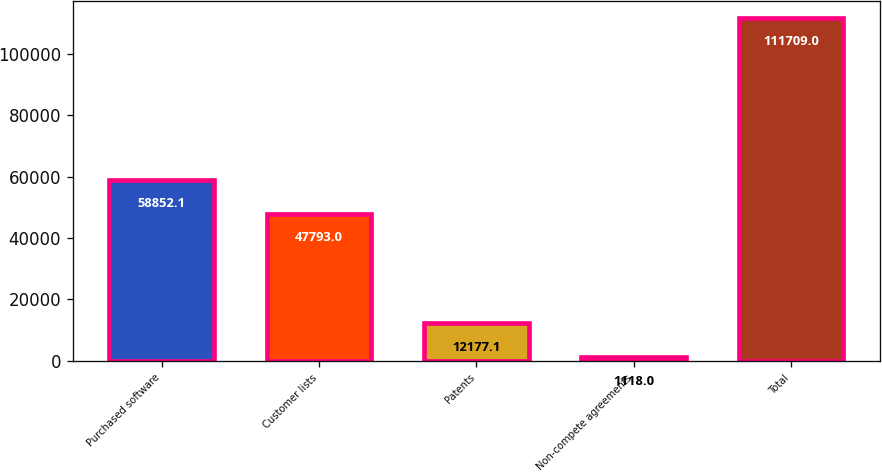Convert chart. <chart><loc_0><loc_0><loc_500><loc_500><bar_chart><fcel>Purchased software<fcel>Customer lists<fcel>Patents<fcel>Non-compete agreements<fcel>Total<nl><fcel>58852.1<fcel>47793<fcel>12177.1<fcel>1118<fcel>111709<nl></chart> 